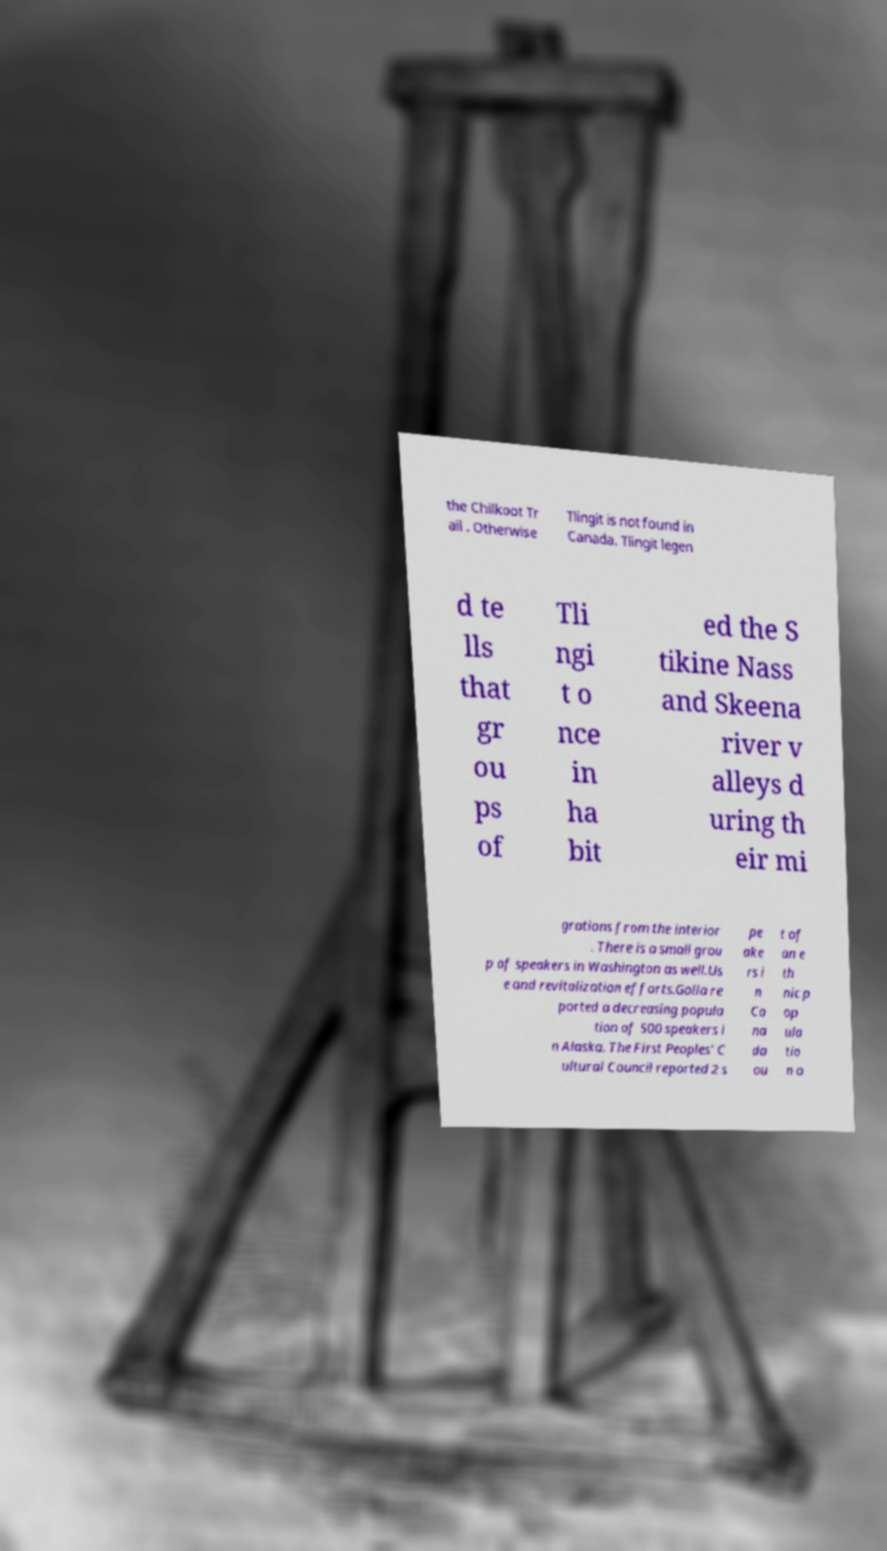Can you accurately transcribe the text from the provided image for me? the Chilkoot Tr ail . Otherwise Tlingit is not found in Canada. Tlingit legen d te lls that gr ou ps of Tli ngi t o nce in ha bit ed the S tikine Nass and Skeena river v alleys d uring th eir mi grations from the interior . There is a small grou p of speakers in Washington as well.Us e and revitalization efforts.Golla re ported a decreasing popula tion of 500 speakers i n Alaska. The First Peoples' C ultural Council reported 2 s pe ake rs i n Ca na da ou t of an e th nic p op ula tio n o 